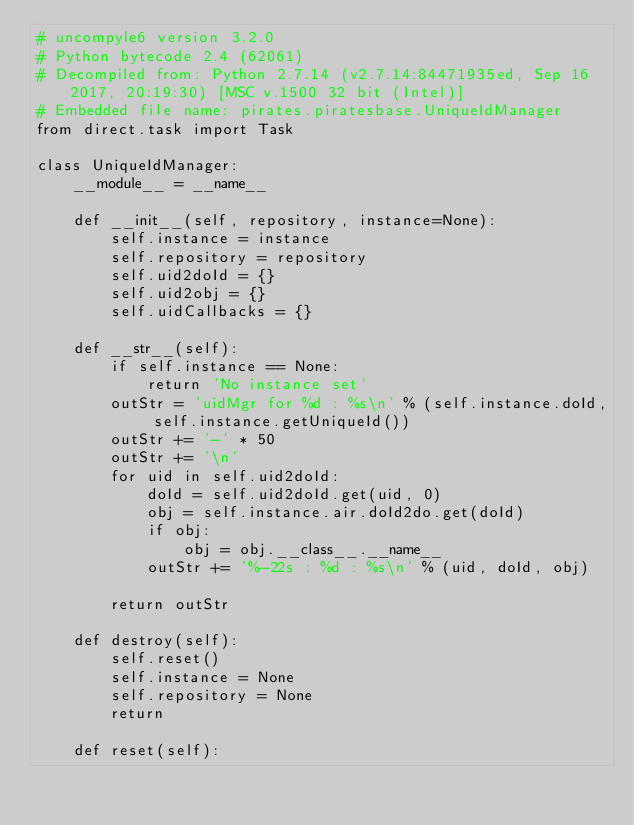<code> <loc_0><loc_0><loc_500><loc_500><_Python_># uncompyle6 version 3.2.0
# Python bytecode 2.4 (62061)
# Decompiled from: Python 2.7.14 (v2.7.14:84471935ed, Sep 16 2017, 20:19:30) [MSC v.1500 32 bit (Intel)]
# Embedded file name: pirates.piratesbase.UniqueIdManager
from direct.task import Task

class UniqueIdManager:
    __module__ = __name__

    def __init__(self, repository, instance=None):
        self.instance = instance
        self.repository = repository
        self.uid2doId = {}
        self.uid2obj = {}
        self.uidCallbacks = {}

    def __str__(self):
        if self.instance == None:
            return 'No instance set'
        outStr = 'uidMgr for %d : %s\n' % (self.instance.doId, self.instance.getUniqueId())
        outStr += '-' * 50
        outStr += '\n'
        for uid in self.uid2doId:
            doId = self.uid2doId.get(uid, 0)
            obj = self.instance.air.doId2do.get(doId)
            if obj:
                obj = obj.__class__.__name__
            outStr += '%-22s : %d : %s\n' % (uid, doId, obj)

        return outStr

    def destroy(self):
        self.reset()
        self.instance = None
        self.repository = None
        return

    def reset(self):</code> 